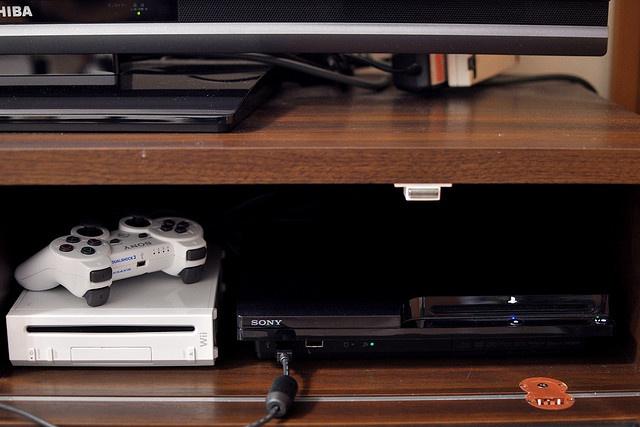Describe the objects in this image and their specific colors. I can see tv in black, gray, lightgray, and darkgray tones and remote in black, darkgray, gray, and lightgray tones in this image. 